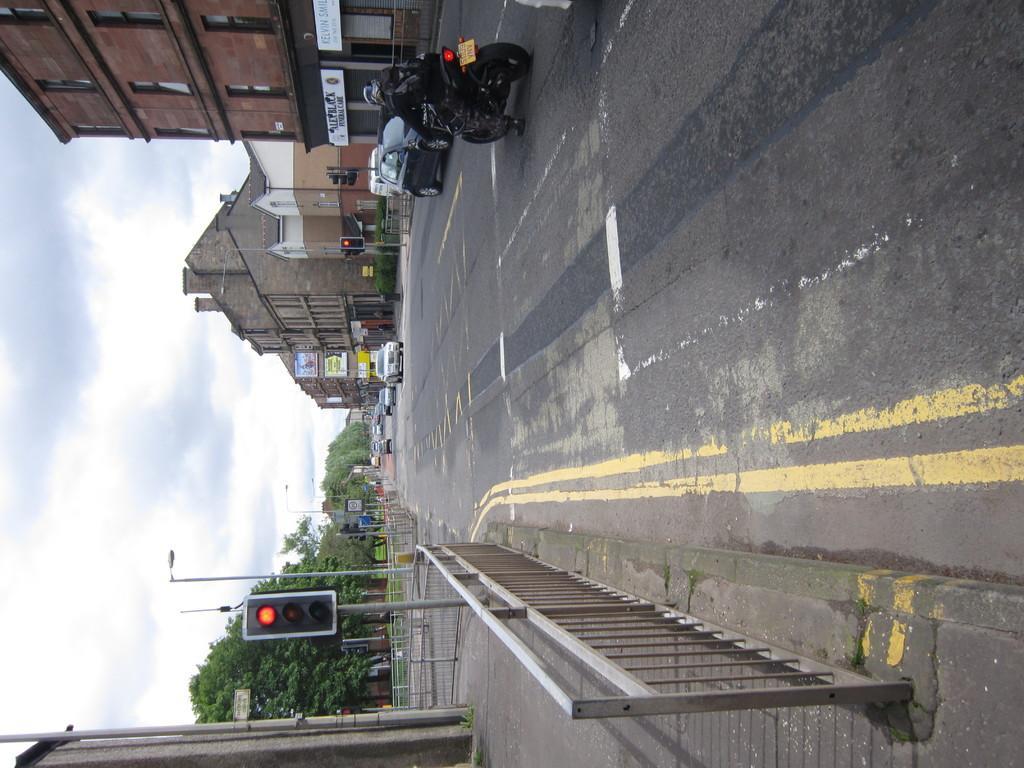Describe this image in one or two sentences. In the foreground I can see a fence, traffic signals and vehicles on the road. In the background I can see buildings, trees and the sky. This image is taken during a day. 